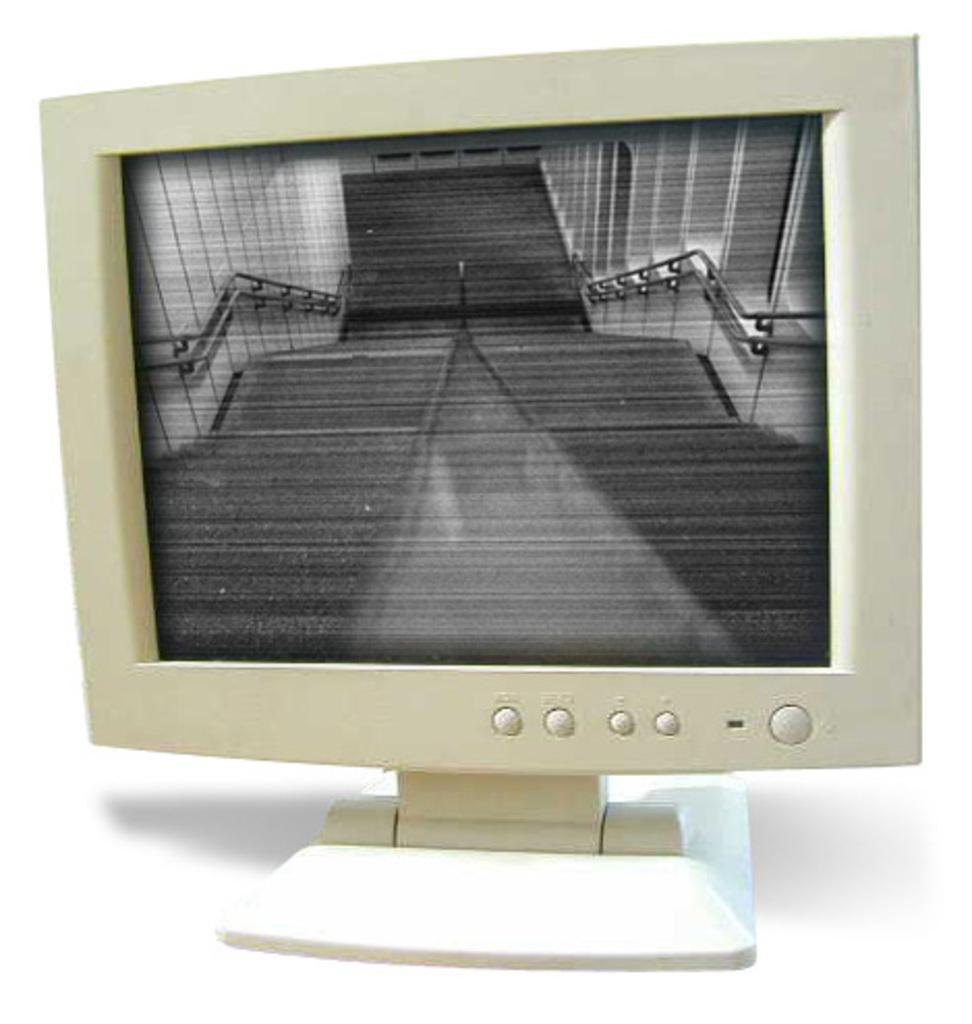What type of furniture is visible in the image? There is a desktop in the image. Can you tell me how many breaths the person in the image is taking? There is no person present in the image, only a desktop. Did the earthquake cause any damage to the desktop in the image? There is no mention of an earthquake in the provided facts, and the image does not show any damage to the desktop. 